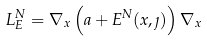<formula> <loc_0><loc_0><loc_500><loc_500>L _ { E } ^ { N } = \nabla _ { x } \left ( a + E ^ { N } ( x , \eta ) \right ) \nabla _ { x }</formula> 